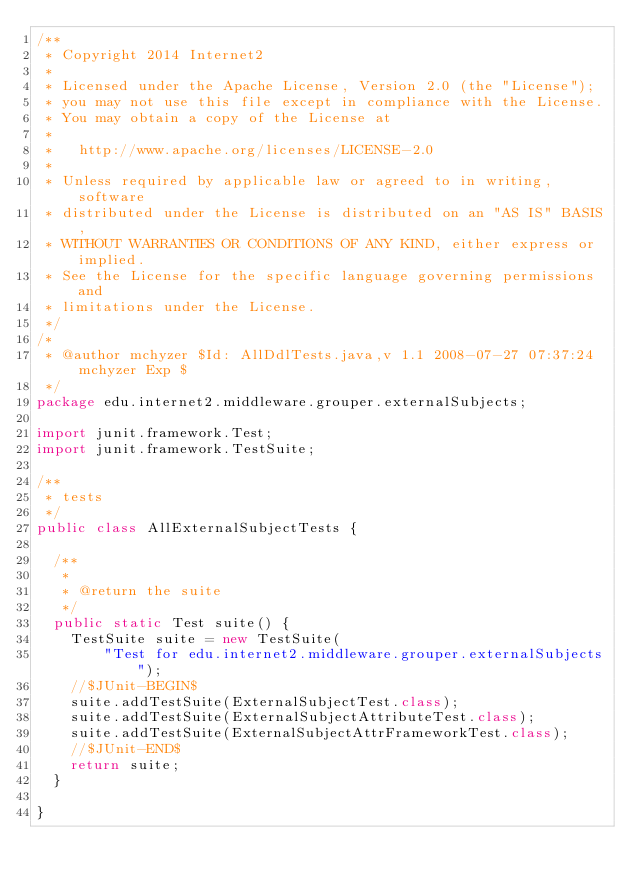Convert code to text. <code><loc_0><loc_0><loc_500><loc_500><_Java_>/**
 * Copyright 2014 Internet2
 *
 * Licensed under the Apache License, Version 2.0 (the "License");
 * you may not use this file except in compliance with the License.
 * You may obtain a copy of the License at
 *
 *   http://www.apache.org/licenses/LICENSE-2.0
 *
 * Unless required by applicable law or agreed to in writing, software
 * distributed under the License is distributed on an "AS IS" BASIS,
 * WITHOUT WARRANTIES OR CONDITIONS OF ANY KIND, either express or implied.
 * See the License for the specific language governing permissions and
 * limitations under the License.
 */
/*
 * @author mchyzer $Id: AllDdlTests.java,v 1.1 2008-07-27 07:37:24 mchyzer Exp $
 */
package edu.internet2.middleware.grouper.externalSubjects;

import junit.framework.Test;
import junit.framework.TestSuite;

/**
 * tests
 */
public class AllExternalSubjectTests {

  /**
   * 
   * @return the suite
   */
  public static Test suite() {
    TestSuite suite = new TestSuite(
        "Test for edu.internet2.middleware.grouper.externalSubjects");
    //$JUnit-BEGIN$
    suite.addTestSuite(ExternalSubjectTest.class);
    suite.addTestSuite(ExternalSubjectAttributeTest.class);
    suite.addTestSuite(ExternalSubjectAttrFrameworkTest.class);
    //$JUnit-END$
    return suite;
  }

}
</code> 